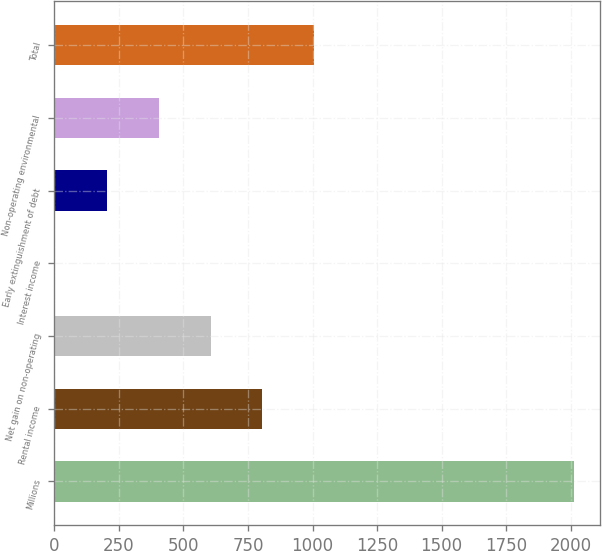Convert chart to OTSL. <chart><loc_0><loc_0><loc_500><loc_500><bar_chart><fcel>Millions<fcel>Rental income<fcel>Net gain on non-operating<fcel>Interest income<fcel>Early extinguishment of debt<fcel>Non-operating environmental<fcel>Total<nl><fcel>2011<fcel>806.2<fcel>605.4<fcel>3<fcel>203.8<fcel>404.6<fcel>1007<nl></chart> 